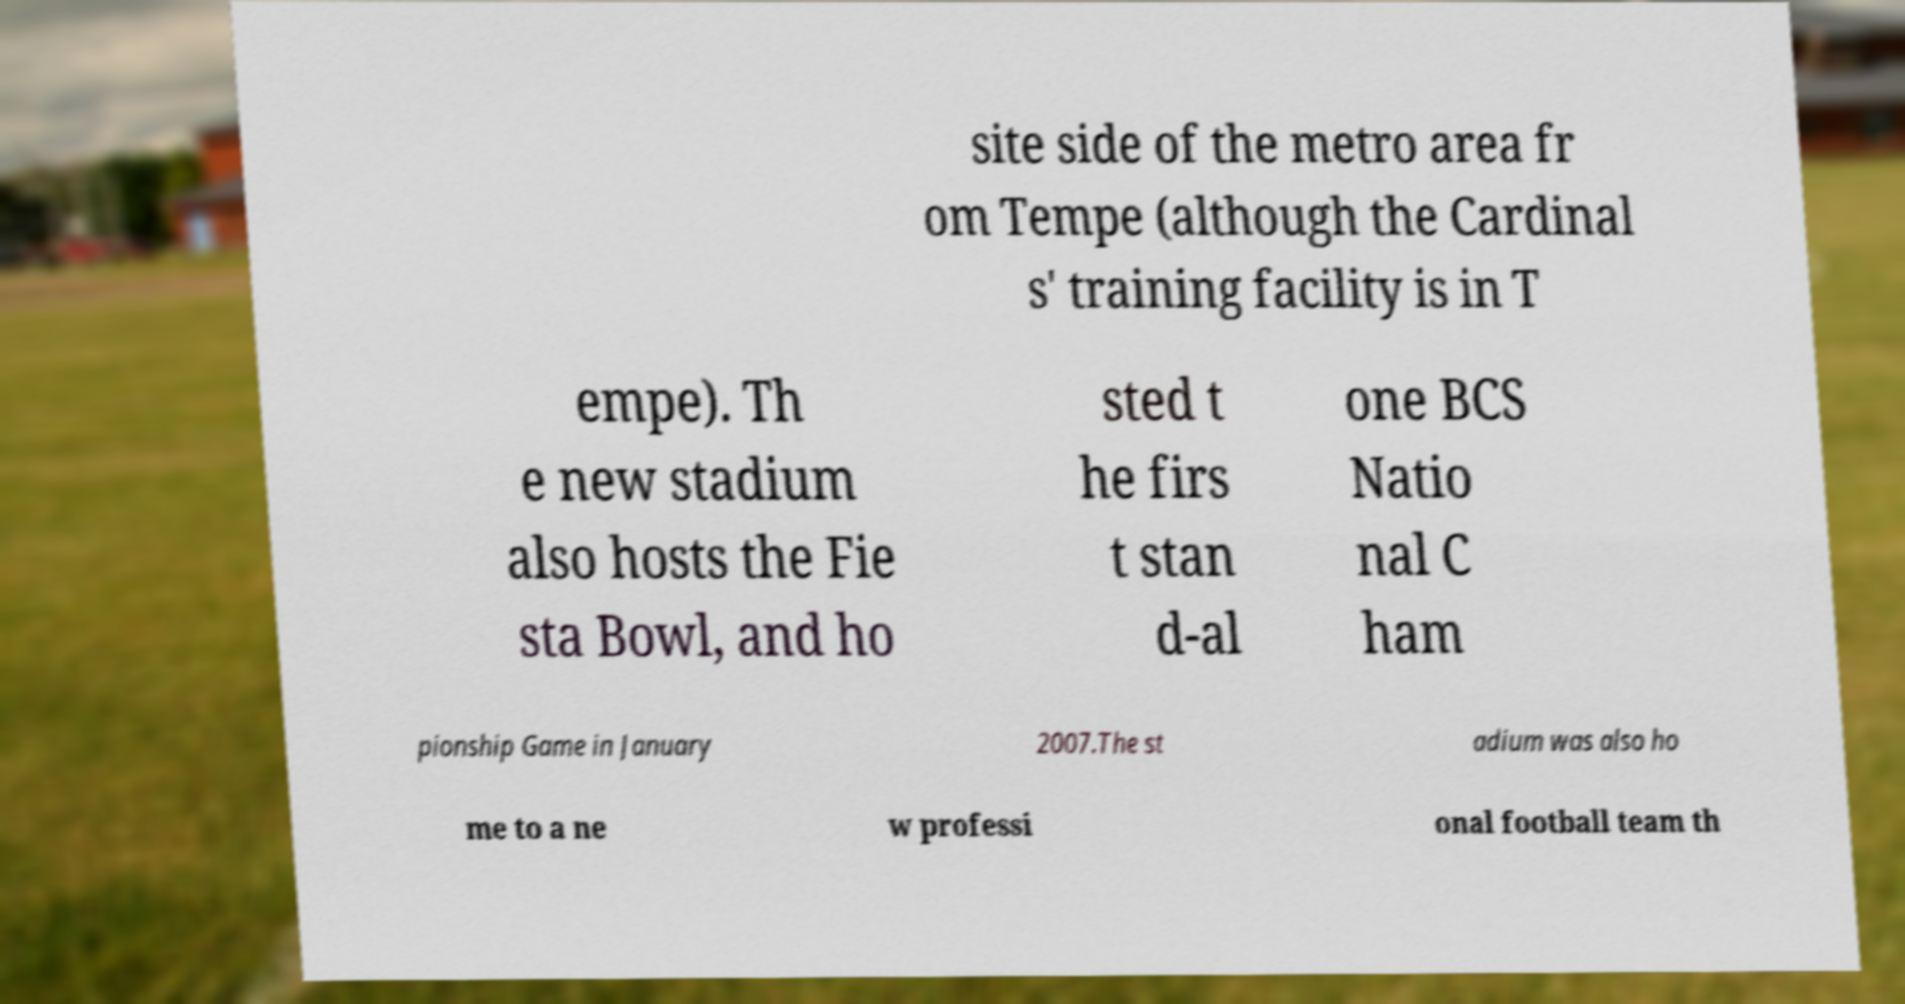Please identify and transcribe the text found in this image. site side of the metro area fr om Tempe (although the Cardinal s' training facility is in T empe). Th e new stadium also hosts the Fie sta Bowl, and ho sted t he firs t stan d-al one BCS Natio nal C ham pionship Game in January 2007.The st adium was also ho me to a ne w professi onal football team th 